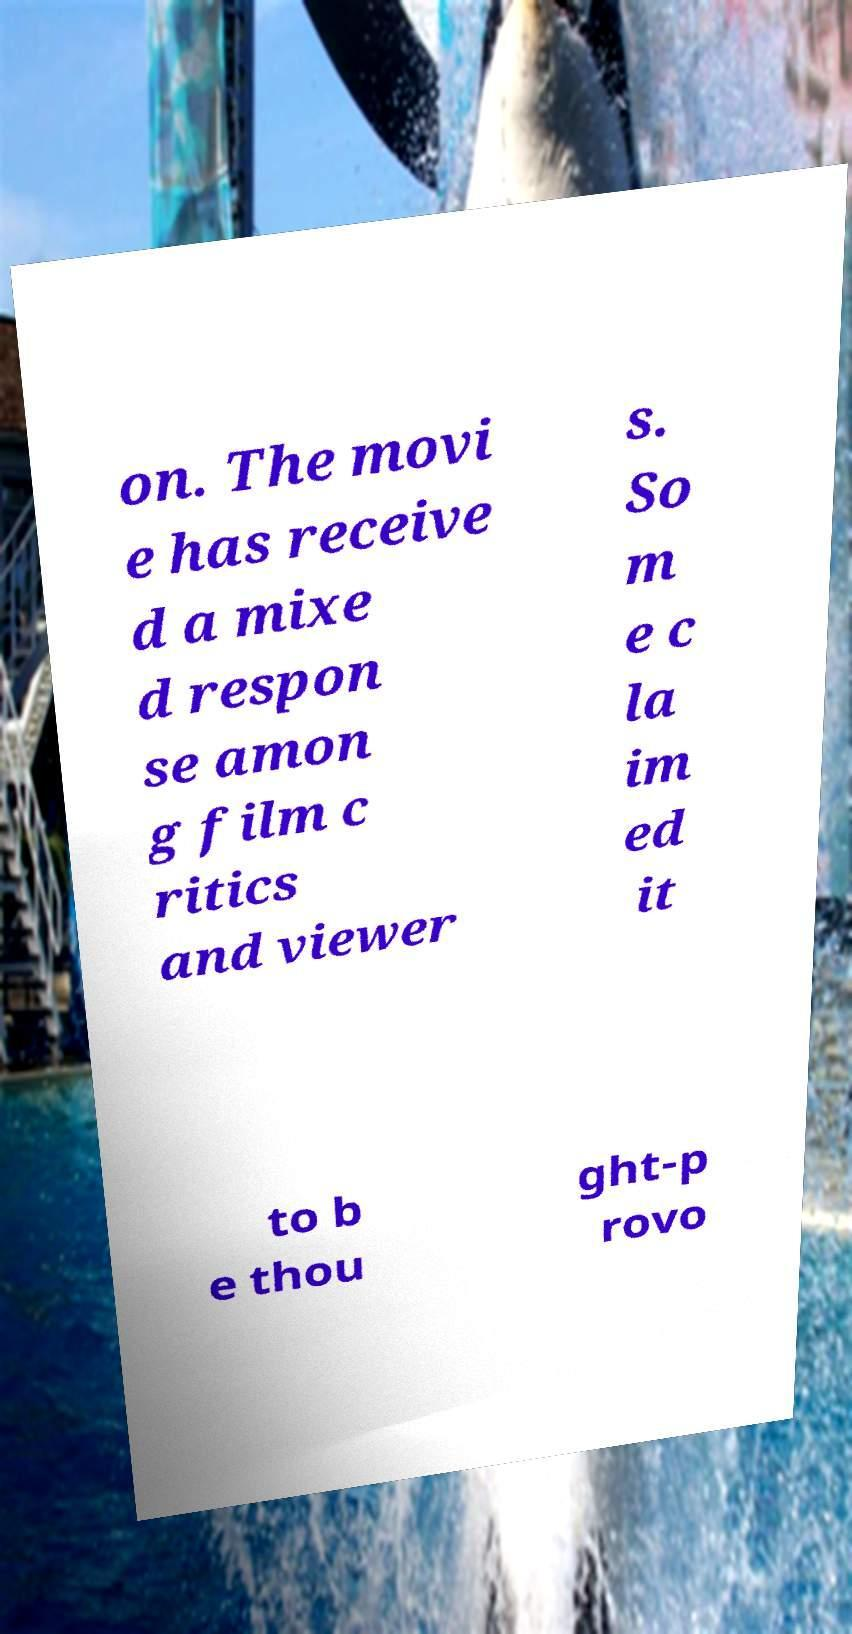Please read and relay the text visible in this image. What does it say? on. The movi e has receive d a mixe d respon se amon g film c ritics and viewer s. So m e c la im ed it to b e thou ght-p rovo 